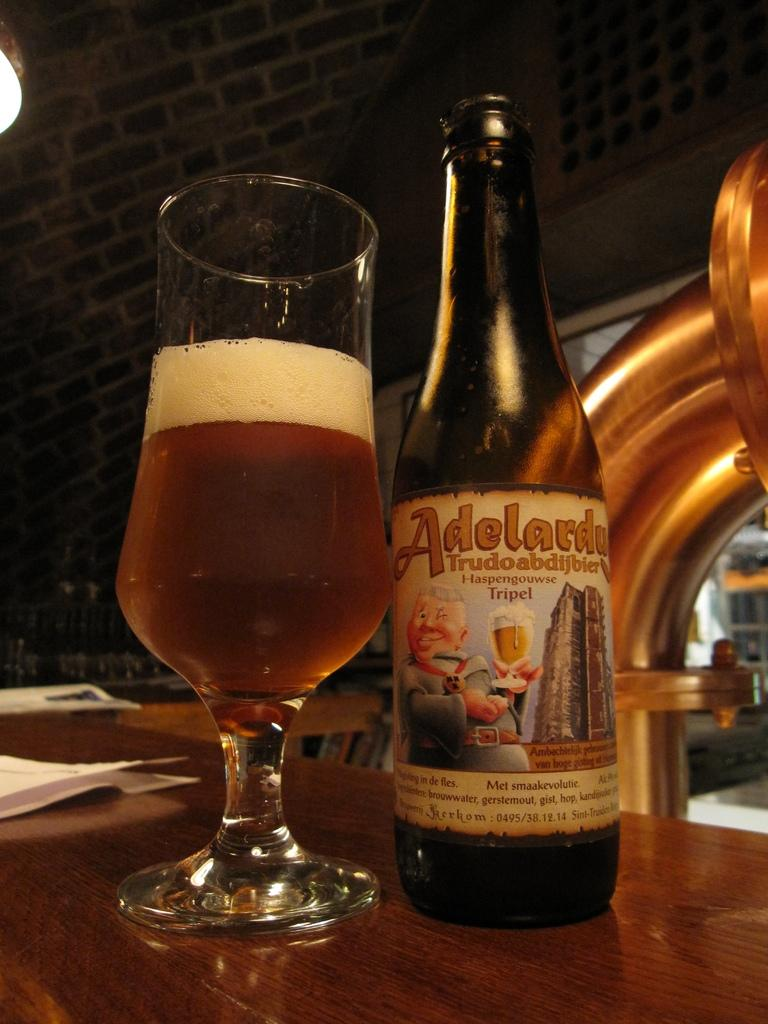<image>
Present a compact description of the photo's key features. A bottle of Adelaru Trudoabdijbier is next to a half full glass. 